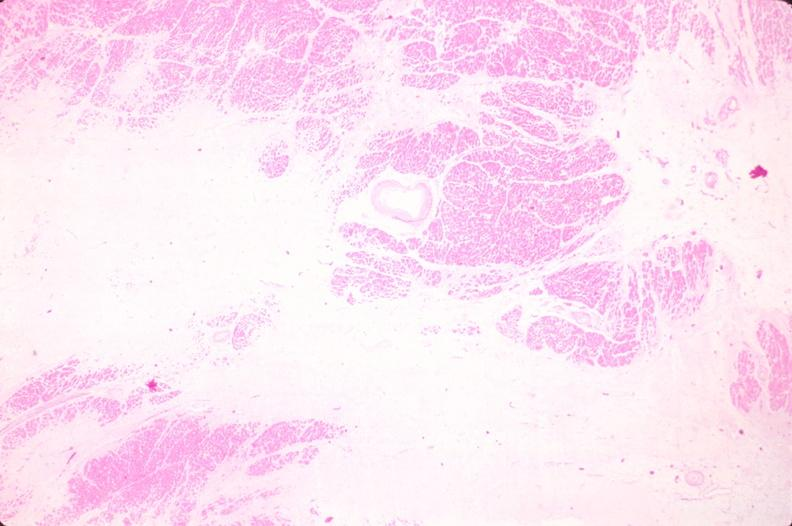does this image show heart, old myocardial infarction with fibrosis, he?
Answer the question using a single word or phrase. Yes 